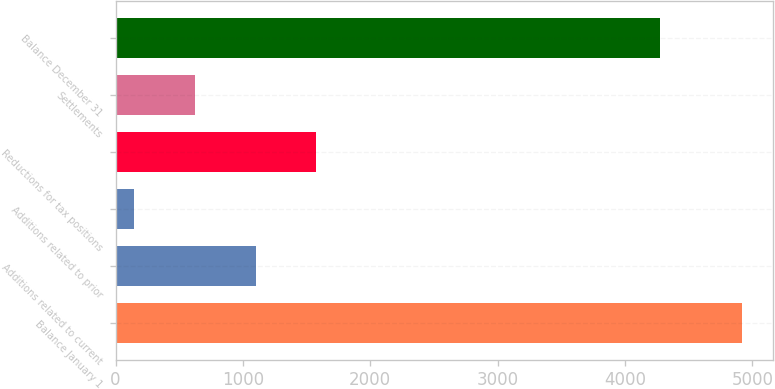<chart> <loc_0><loc_0><loc_500><loc_500><bar_chart><fcel>Balance January 1<fcel>Additions related to current<fcel>Additions related to prior<fcel>Reductions for tax positions<fcel>Settlements<fcel>Balance December 31<nl><fcel>4919<fcel>1099.8<fcel>145<fcel>1577.2<fcel>622.4<fcel>4277<nl></chart> 